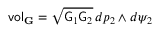Convert formula to latex. <formula><loc_0><loc_0><loc_500><loc_500>v o l _ { G } = \sqrt { G _ { 1 } G _ { 2 } } \, d p _ { 2 } \wedge d \psi _ { 2 }</formula> 